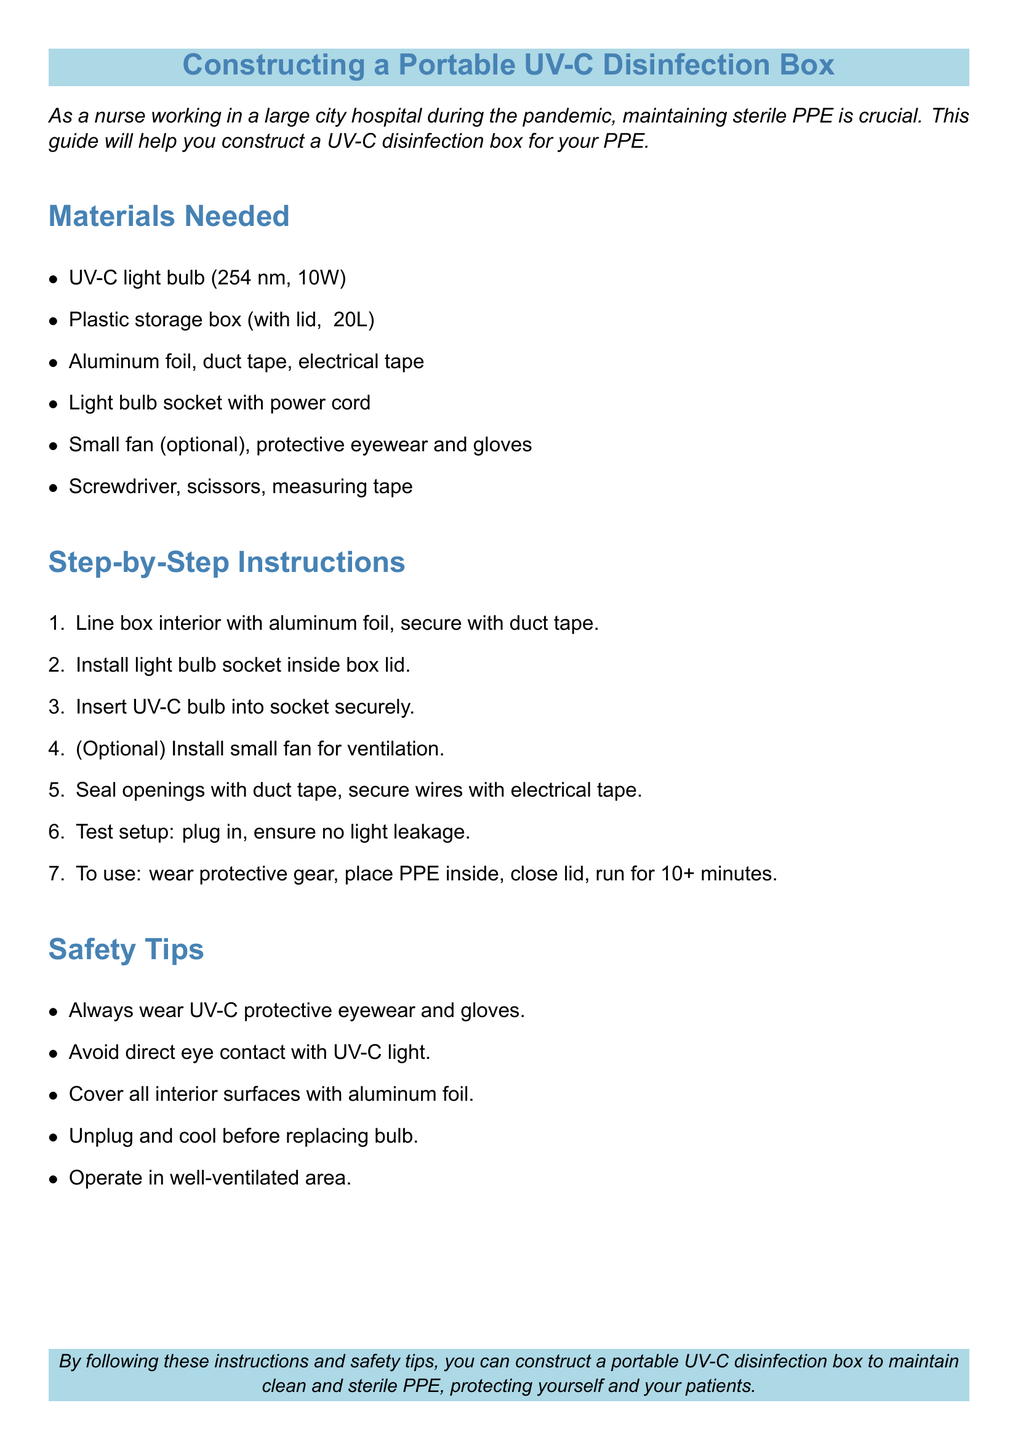What type of light bulb is used? The document specifies that a 254 nm, 10W UV-C light bulb is needed.
Answer: 254 nm, 10W How many liters is the plastic storage box? The document states that the plastic storage box should be approximately 20 liters in size.
Answer: ~20L What is used to line the box interior? The instructions indicate that aluminum foil is used to line the box interior.
Answer: Aluminum foil What safety item must be worn? The document states that protective eyewear is a required safety item.
Answer: Protective eyewear What is the minimum running time for the UV-C box? According to the instructions, the box should run for at least 10 minutes.
Answer: 10+ minutes Why should all interior surfaces be covered? The document emphasizes that covering all surfaces ensures effective UV-C disinfection.
Answer: Effective UV-C disinfection What tool is needed to secure the light bulb in place? The document mentions that a screwdriver is needed for securing the socket.
Answer: Screwdriver What should you do before replacing the bulb? The document advises to unplug and cool the device before replacing the bulb.
Answer: Unplug and cool What is the optional component mentioned for ventilation? The instructions suggest that a small fan can be included for ventilation.
Answer: Small fan 